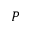<formula> <loc_0><loc_0><loc_500><loc_500>P</formula> 